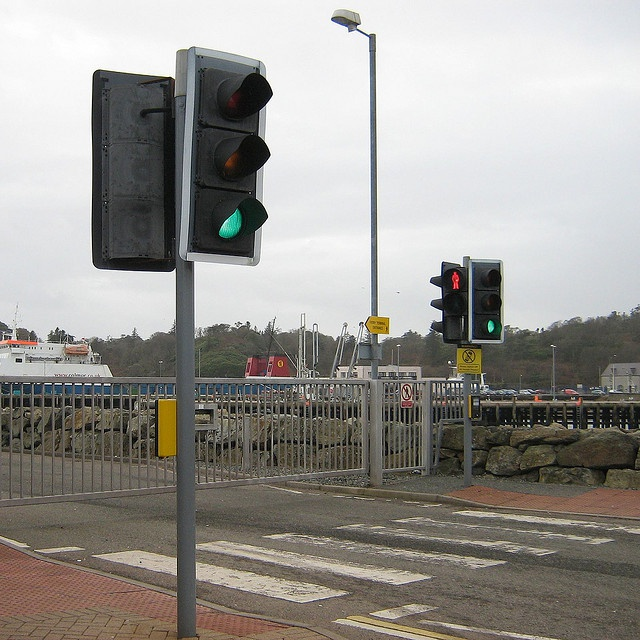Describe the objects in this image and their specific colors. I can see traffic light in white, black, darkgray, gray, and purple tones, traffic light in white, black, and purple tones, boat in white, lightgray, darkgray, and gray tones, traffic light in white, black, darkgray, purple, and navy tones, and traffic light in white, black, and gray tones in this image. 